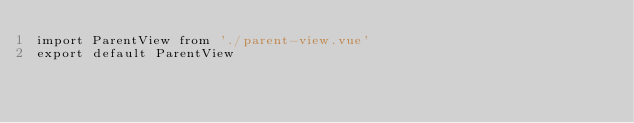<code> <loc_0><loc_0><loc_500><loc_500><_JavaScript_>import ParentView from './parent-view.vue'
export default ParentView</code> 